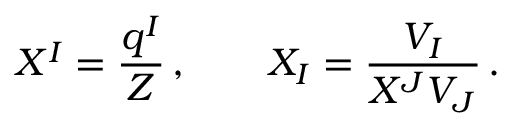<formula> <loc_0><loc_0><loc_500><loc_500>X ^ { I } = \frac { q ^ { I } } { Z } \, , \quad X _ { I } = \frac { V _ { I } } { X ^ { J } V _ { J } } \, .</formula> 